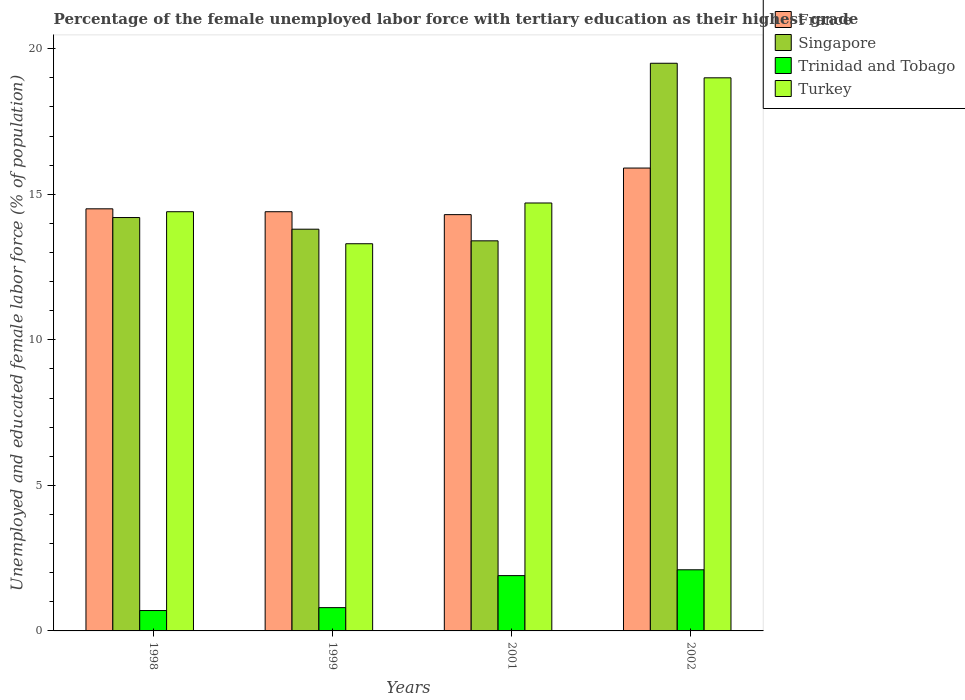How many different coloured bars are there?
Offer a terse response. 4. Are the number of bars per tick equal to the number of legend labels?
Your response must be concise. Yes. How many bars are there on the 4th tick from the left?
Your answer should be compact. 4. How many bars are there on the 4th tick from the right?
Provide a short and direct response. 4. In how many cases, is the number of bars for a given year not equal to the number of legend labels?
Your answer should be compact. 0. Across all years, what is the maximum percentage of the unemployed female labor force with tertiary education in Trinidad and Tobago?
Offer a very short reply. 2.1. Across all years, what is the minimum percentage of the unemployed female labor force with tertiary education in Trinidad and Tobago?
Your answer should be very brief. 0.7. In which year was the percentage of the unemployed female labor force with tertiary education in Trinidad and Tobago maximum?
Keep it short and to the point. 2002. In which year was the percentage of the unemployed female labor force with tertiary education in France minimum?
Provide a short and direct response. 2001. What is the total percentage of the unemployed female labor force with tertiary education in Trinidad and Tobago in the graph?
Your answer should be very brief. 5.5. What is the difference between the percentage of the unemployed female labor force with tertiary education in Turkey in 1998 and that in 1999?
Give a very brief answer. 1.1. What is the difference between the percentage of the unemployed female labor force with tertiary education in Turkey in 1998 and the percentage of the unemployed female labor force with tertiary education in Singapore in 1999?
Make the answer very short. 0.6. What is the average percentage of the unemployed female labor force with tertiary education in Turkey per year?
Make the answer very short. 15.35. In the year 1998, what is the difference between the percentage of the unemployed female labor force with tertiary education in Trinidad and Tobago and percentage of the unemployed female labor force with tertiary education in Turkey?
Give a very brief answer. -13.7. What is the ratio of the percentage of the unemployed female labor force with tertiary education in Singapore in 1998 to that in 2001?
Offer a very short reply. 1.06. Is the percentage of the unemployed female labor force with tertiary education in Trinidad and Tobago in 1998 less than that in 2002?
Keep it short and to the point. Yes. Is the difference between the percentage of the unemployed female labor force with tertiary education in Trinidad and Tobago in 1998 and 2002 greater than the difference between the percentage of the unemployed female labor force with tertiary education in Turkey in 1998 and 2002?
Your answer should be very brief. Yes. What is the difference between the highest and the second highest percentage of the unemployed female labor force with tertiary education in France?
Give a very brief answer. 1.4. What is the difference between the highest and the lowest percentage of the unemployed female labor force with tertiary education in France?
Provide a short and direct response. 1.6. Is the sum of the percentage of the unemployed female labor force with tertiary education in Singapore in 2001 and 2002 greater than the maximum percentage of the unemployed female labor force with tertiary education in France across all years?
Your response must be concise. Yes. Is it the case that in every year, the sum of the percentage of the unemployed female labor force with tertiary education in Turkey and percentage of the unemployed female labor force with tertiary education in Singapore is greater than the sum of percentage of the unemployed female labor force with tertiary education in Trinidad and Tobago and percentage of the unemployed female labor force with tertiary education in France?
Provide a succinct answer. No. What does the 2nd bar from the left in 1999 represents?
Keep it short and to the point. Singapore. What does the 2nd bar from the right in 2001 represents?
Provide a short and direct response. Trinidad and Tobago. Are all the bars in the graph horizontal?
Offer a very short reply. No. What is the difference between two consecutive major ticks on the Y-axis?
Your answer should be very brief. 5. Are the values on the major ticks of Y-axis written in scientific E-notation?
Give a very brief answer. No. How many legend labels are there?
Your response must be concise. 4. What is the title of the graph?
Your answer should be compact. Percentage of the female unemployed labor force with tertiary education as their highest grade. Does "Colombia" appear as one of the legend labels in the graph?
Keep it short and to the point. No. What is the label or title of the X-axis?
Make the answer very short. Years. What is the label or title of the Y-axis?
Your response must be concise. Unemployed and educated female labor force (% of population). What is the Unemployed and educated female labor force (% of population) of Singapore in 1998?
Your response must be concise. 14.2. What is the Unemployed and educated female labor force (% of population) in Trinidad and Tobago in 1998?
Make the answer very short. 0.7. What is the Unemployed and educated female labor force (% of population) in Turkey in 1998?
Make the answer very short. 14.4. What is the Unemployed and educated female labor force (% of population) of France in 1999?
Your answer should be very brief. 14.4. What is the Unemployed and educated female labor force (% of population) of Singapore in 1999?
Give a very brief answer. 13.8. What is the Unemployed and educated female labor force (% of population) of Trinidad and Tobago in 1999?
Your answer should be compact. 0.8. What is the Unemployed and educated female labor force (% of population) in Turkey in 1999?
Ensure brevity in your answer.  13.3. What is the Unemployed and educated female labor force (% of population) in France in 2001?
Your answer should be very brief. 14.3. What is the Unemployed and educated female labor force (% of population) in Singapore in 2001?
Give a very brief answer. 13.4. What is the Unemployed and educated female labor force (% of population) of Trinidad and Tobago in 2001?
Provide a short and direct response. 1.9. What is the Unemployed and educated female labor force (% of population) of Turkey in 2001?
Offer a very short reply. 14.7. What is the Unemployed and educated female labor force (% of population) in France in 2002?
Ensure brevity in your answer.  15.9. What is the Unemployed and educated female labor force (% of population) in Singapore in 2002?
Offer a terse response. 19.5. What is the Unemployed and educated female labor force (% of population) in Trinidad and Tobago in 2002?
Provide a short and direct response. 2.1. What is the Unemployed and educated female labor force (% of population) of Turkey in 2002?
Your answer should be very brief. 19. Across all years, what is the maximum Unemployed and educated female labor force (% of population) of France?
Provide a succinct answer. 15.9. Across all years, what is the maximum Unemployed and educated female labor force (% of population) of Trinidad and Tobago?
Provide a succinct answer. 2.1. Across all years, what is the minimum Unemployed and educated female labor force (% of population) in France?
Keep it short and to the point. 14.3. Across all years, what is the minimum Unemployed and educated female labor force (% of population) of Singapore?
Ensure brevity in your answer.  13.4. Across all years, what is the minimum Unemployed and educated female labor force (% of population) of Trinidad and Tobago?
Your answer should be compact. 0.7. Across all years, what is the minimum Unemployed and educated female labor force (% of population) in Turkey?
Offer a terse response. 13.3. What is the total Unemployed and educated female labor force (% of population) in France in the graph?
Keep it short and to the point. 59.1. What is the total Unemployed and educated female labor force (% of population) in Singapore in the graph?
Keep it short and to the point. 60.9. What is the total Unemployed and educated female labor force (% of population) in Trinidad and Tobago in the graph?
Make the answer very short. 5.5. What is the total Unemployed and educated female labor force (% of population) of Turkey in the graph?
Your response must be concise. 61.4. What is the difference between the Unemployed and educated female labor force (% of population) in France in 1998 and that in 1999?
Offer a terse response. 0.1. What is the difference between the Unemployed and educated female labor force (% of population) of Turkey in 1998 and that in 2001?
Your answer should be compact. -0.3. What is the difference between the Unemployed and educated female labor force (% of population) in France in 1998 and that in 2002?
Give a very brief answer. -1.4. What is the difference between the Unemployed and educated female labor force (% of population) of Trinidad and Tobago in 1998 and that in 2002?
Your response must be concise. -1.4. What is the difference between the Unemployed and educated female labor force (% of population) in Trinidad and Tobago in 1999 and that in 2001?
Give a very brief answer. -1.1. What is the difference between the Unemployed and educated female labor force (% of population) in Singapore in 1999 and that in 2002?
Keep it short and to the point. -5.7. What is the difference between the Unemployed and educated female labor force (% of population) in Singapore in 2001 and that in 2002?
Give a very brief answer. -6.1. What is the difference between the Unemployed and educated female labor force (% of population) in France in 1998 and the Unemployed and educated female labor force (% of population) in Singapore in 1999?
Offer a very short reply. 0.7. What is the difference between the Unemployed and educated female labor force (% of population) of France in 1998 and the Unemployed and educated female labor force (% of population) of Trinidad and Tobago in 1999?
Keep it short and to the point. 13.7. What is the difference between the Unemployed and educated female labor force (% of population) of Trinidad and Tobago in 1998 and the Unemployed and educated female labor force (% of population) of Turkey in 1999?
Ensure brevity in your answer.  -12.6. What is the difference between the Unemployed and educated female labor force (% of population) of France in 1998 and the Unemployed and educated female labor force (% of population) of Singapore in 2001?
Your answer should be compact. 1.1. What is the difference between the Unemployed and educated female labor force (% of population) of France in 1998 and the Unemployed and educated female labor force (% of population) of Trinidad and Tobago in 2001?
Keep it short and to the point. 12.6. What is the difference between the Unemployed and educated female labor force (% of population) of France in 1998 and the Unemployed and educated female labor force (% of population) of Turkey in 2001?
Your answer should be very brief. -0.2. What is the difference between the Unemployed and educated female labor force (% of population) in Trinidad and Tobago in 1998 and the Unemployed and educated female labor force (% of population) in Turkey in 2001?
Give a very brief answer. -14. What is the difference between the Unemployed and educated female labor force (% of population) of France in 1998 and the Unemployed and educated female labor force (% of population) of Turkey in 2002?
Provide a short and direct response. -4.5. What is the difference between the Unemployed and educated female labor force (% of population) in Trinidad and Tobago in 1998 and the Unemployed and educated female labor force (% of population) in Turkey in 2002?
Your response must be concise. -18.3. What is the difference between the Unemployed and educated female labor force (% of population) in France in 1999 and the Unemployed and educated female labor force (% of population) in Turkey in 2001?
Provide a succinct answer. -0.3. What is the difference between the Unemployed and educated female labor force (% of population) of Singapore in 1999 and the Unemployed and educated female labor force (% of population) of Trinidad and Tobago in 2001?
Your response must be concise. 11.9. What is the difference between the Unemployed and educated female labor force (% of population) of Trinidad and Tobago in 1999 and the Unemployed and educated female labor force (% of population) of Turkey in 2001?
Keep it short and to the point. -13.9. What is the difference between the Unemployed and educated female labor force (% of population) in Singapore in 1999 and the Unemployed and educated female labor force (% of population) in Trinidad and Tobago in 2002?
Keep it short and to the point. 11.7. What is the difference between the Unemployed and educated female labor force (% of population) in Singapore in 1999 and the Unemployed and educated female labor force (% of population) in Turkey in 2002?
Your answer should be very brief. -5.2. What is the difference between the Unemployed and educated female labor force (% of population) in Trinidad and Tobago in 1999 and the Unemployed and educated female labor force (% of population) in Turkey in 2002?
Offer a very short reply. -18.2. What is the difference between the Unemployed and educated female labor force (% of population) of France in 2001 and the Unemployed and educated female labor force (% of population) of Singapore in 2002?
Keep it short and to the point. -5.2. What is the difference between the Unemployed and educated female labor force (% of population) in Trinidad and Tobago in 2001 and the Unemployed and educated female labor force (% of population) in Turkey in 2002?
Keep it short and to the point. -17.1. What is the average Unemployed and educated female labor force (% of population) in France per year?
Offer a very short reply. 14.78. What is the average Unemployed and educated female labor force (% of population) in Singapore per year?
Provide a succinct answer. 15.22. What is the average Unemployed and educated female labor force (% of population) of Trinidad and Tobago per year?
Your answer should be very brief. 1.38. What is the average Unemployed and educated female labor force (% of population) of Turkey per year?
Your answer should be compact. 15.35. In the year 1998, what is the difference between the Unemployed and educated female labor force (% of population) of France and Unemployed and educated female labor force (% of population) of Trinidad and Tobago?
Keep it short and to the point. 13.8. In the year 1998, what is the difference between the Unemployed and educated female labor force (% of population) of France and Unemployed and educated female labor force (% of population) of Turkey?
Your answer should be compact. 0.1. In the year 1998, what is the difference between the Unemployed and educated female labor force (% of population) in Trinidad and Tobago and Unemployed and educated female labor force (% of population) in Turkey?
Keep it short and to the point. -13.7. In the year 1999, what is the difference between the Unemployed and educated female labor force (% of population) in France and Unemployed and educated female labor force (% of population) in Singapore?
Keep it short and to the point. 0.6. In the year 1999, what is the difference between the Unemployed and educated female labor force (% of population) in France and Unemployed and educated female labor force (% of population) in Trinidad and Tobago?
Keep it short and to the point. 13.6. In the year 1999, what is the difference between the Unemployed and educated female labor force (% of population) in Singapore and Unemployed and educated female labor force (% of population) in Trinidad and Tobago?
Offer a very short reply. 13. In the year 1999, what is the difference between the Unemployed and educated female labor force (% of population) in Singapore and Unemployed and educated female labor force (% of population) in Turkey?
Your answer should be compact. 0.5. In the year 2001, what is the difference between the Unemployed and educated female labor force (% of population) of France and Unemployed and educated female labor force (% of population) of Turkey?
Your answer should be very brief. -0.4. In the year 2001, what is the difference between the Unemployed and educated female labor force (% of population) in Singapore and Unemployed and educated female labor force (% of population) in Turkey?
Offer a very short reply. -1.3. In the year 2002, what is the difference between the Unemployed and educated female labor force (% of population) in Trinidad and Tobago and Unemployed and educated female labor force (% of population) in Turkey?
Your answer should be compact. -16.9. What is the ratio of the Unemployed and educated female labor force (% of population) of France in 1998 to that in 1999?
Keep it short and to the point. 1.01. What is the ratio of the Unemployed and educated female labor force (% of population) in Trinidad and Tobago in 1998 to that in 1999?
Ensure brevity in your answer.  0.88. What is the ratio of the Unemployed and educated female labor force (% of population) in Turkey in 1998 to that in 1999?
Keep it short and to the point. 1.08. What is the ratio of the Unemployed and educated female labor force (% of population) in Singapore in 1998 to that in 2001?
Provide a succinct answer. 1.06. What is the ratio of the Unemployed and educated female labor force (% of population) in Trinidad and Tobago in 1998 to that in 2001?
Your answer should be very brief. 0.37. What is the ratio of the Unemployed and educated female labor force (% of population) in Turkey in 1998 to that in 2001?
Give a very brief answer. 0.98. What is the ratio of the Unemployed and educated female labor force (% of population) of France in 1998 to that in 2002?
Offer a terse response. 0.91. What is the ratio of the Unemployed and educated female labor force (% of population) in Singapore in 1998 to that in 2002?
Make the answer very short. 0.73. What is the ratio of the Unemployed and educated female labor force (% of population) of Turkey in 1998 to that in 2002?
Your response must be concise. 0.76. What is the ratio of the Unemployed and educated female labor force (% of population) in France in 1999 to that in 2001?
Offer a very short reply. 1.01. What is the ratio of the Unemployed and educated female labor force (% of population) in Singapore in 1999 to that in 2001?
Provide a succinct answer. 1.03. What is the ratio of the Unemployed and educated female labor force (% of population) of Trinidad and Tobago in 1999 to that in 2001?
Keep it short and to the point. 0.42. What is the ratio of the Unemployed and educated female labor force (% of population) of Turkey in 1999 to that in 2001?
Ensure brevity in your answer.  0.9. What is the ratio of the Unemployed and educated female labor force (% of population) of France in 1999 to that in 2002?
Offer a very short reply. 0.91. What is the ratio of the Unemployed and educated female labor force (% of population) in Singapore in 1999 to that in 2002?
Keep it short and to the point. 0.71. What is the ratio of the Unemployed and educated female labor force (% of population) of Trinidad and Tobago in 1999 to that in 2002?
Ensure brevity in your answer.  0.38. What is the ratio of the Unemployed and educated female labor force (% of population) in Turkey in 1999 to that in 2002?
Offer a terse response. 0.7. What is the ratio of the Unemployed and educated female labor force (% of population) in France in 2001 to that in 2002?
Make the answer very short. 0.9. What is the ratio of the Unemployed and educated female labor force (% of population) of Singapore in 2001 to that in 2002?
Offer a terse response. 0.69. What is the ratio of the Unemployed and educated female labor force (% of population) of Trinidad and Tobago in 2001 to that in 2002?
Your response must be concise. 0.9. What is the ratio of the Unemployed and educated female labor force (% of population) of Turkey in 2001 to that in 2002?
Offer a very short reply. 0.77. What is the difference between the highest and the second highest Unemployed and educated female labor force (% of population) of Trinidad and Tobago?
Make the answer very short. 0.2. What is the difference between the highest and the lowest Unemployed and educated female labor force (% of population) in France?
Provide a short and direct response. 1.6. What is the difference between the highest and the lowest Unemployed and educated female labor force (% of population) of Singapore?
Give a very brief answer. 6.1. What is the difference between the highest and the lowest Unemployed and educated female labor force (% of population) in Turkey?
Give a very brief answer. 5.7. 